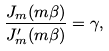<formula> <loc_0><loc_0><loc_500><loc_500>\frac { J _ { m } ( m \beta ) } { J _ { m } ^ { \prime } ( m \beta ) } = \gamma ,</formula> 